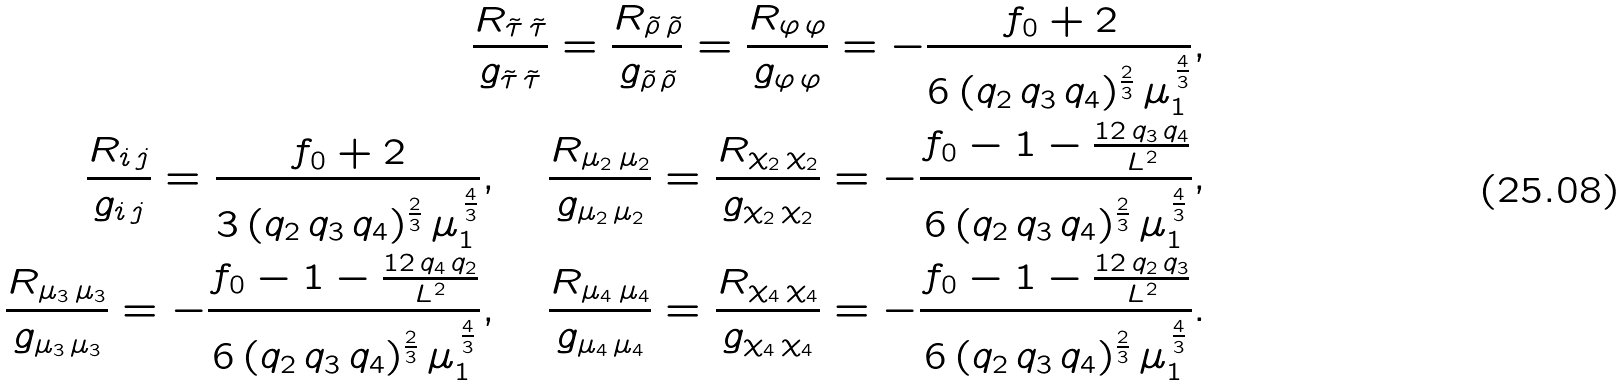Convert formula to latex. <formula><loc_0><loc_0><loc_500><loc_500>\frac { R _ { { \tilde { \tau } } \, { \tilde { \tau } } } } { g _ { { \tilde { \tau } } \, { \tilde { \tau } } } } = \frac { R _ { { \tilde { \rho } } \, { \tilde { \rho } } } } { g _ { { \tilde { \rho } } \, { \tilde { \rho } } } } = \frac { R _ { \varphi \, \varphi } } { g _ { \varphi \, \varphi } } = - \frac { f _ { 0 } + 2 } { 6 \, ( q _ { 2 } \, q _ { 3 } \, q _ { 4 } ) ^ { \frac { 2 } { 3 } } \, \mu _ { 1 } ^ { \, \frac { 4 } { 3 } } } , \\ \frac { R _ { i \, j } } { g _ { i \, j } } = \frac { f _ { 0 } + 2 } { 3 \, ( q _ { 2 } \, q _ { 3 } \, q _ { 4 } ) ^ { \frac { 2 } { 3 } } \, \mu _ { 1 } ^ { \, \frac { 4 } { 3 } } } , \quad \frac { R _ { \mu _ { 2 } \, \mu _ { 2 } } } { g _ { \mu _ { 2 } \, \mu _ { 2 } } } = \frac { R _ { \chi _ { 2 } \, \chi _ { 2 } } } { g _ { \chi _ { 2 } \, \chi _ { 2 } } } = - \frac { f _ { 0 } - 1 - \frac { 1 2 \, q _ { 3 } \, q _ { 4 } } { L ^ { 2 } } } { 6 \, ( q _ { 2 } \, q _ { 3 } \, q _ { 4 } ) ^ { \frac { 2 } { 3 } } \, \mu _ { 1 } ^ { \, \frac { 4 } { 3 } } } , \\ \frac { R _ { \mu _ { 3 } \, \mu _ { 3 } } } { g _ { \mu _ { 3 } \, \mu _ { 3 } } } = - \frac { f _ { 0 } - 1 - \frac { 1 2 \, q _ { 4 } \, q _ { 2 } } { L ^ { 2 } } } { 6 \, ( q _ { 2 } \, q _ { 3 } \, q _ { 4 } ) ^ { \frac { 2 } { 3 } } \, \mu _ { 1 } ^ { \, \frac { 4 } { 3 } } } , \quad \frac { R _ { \mu _ { 4 } \, \mu _ { 4 } } } { g _ { \mu _ { 4 } \, \mu _ { 4 } } } = \frac { R _ { \chi _ { 4 } \, \chi _ { 4 } } } { g _ { \chi _ { 4 } \, \chi _ { 4 } } } = - \frac { f _ { 0 } - 1 - \frac { 1 2 \, q _ { 2 } \, q _ { 3 } } { L ^ { 2 } } } { 6 \, ( q _ { 2 } \, q _ { 3 } \, q _ { 4 } ) ^ { \frac { 2 } { 3 } } \, \mu _ { 1 } ^ { \, \frac { 4 } { 3 } } } .</formula> 